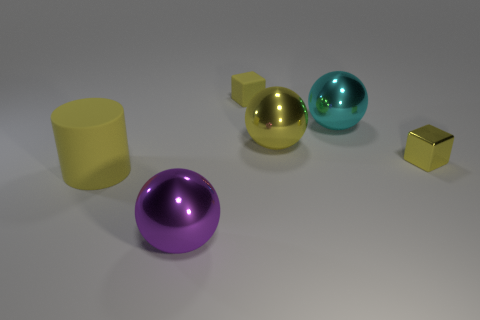There is a large ball that is the same color as the small matte cube; what is its material?
Your answer should be very brief. Metal. Is the number of yellow metal blocks that are on the left side of the purple metallic object the same as the number of matte objects that are to the right of the cylinder?
Provide a succinct answer. No. Is there any other thing that is the same size as the yellow matte cylinder?
Offer a terse response. Yes. There is a cyan object that is the same shape as the big purple object; what is its material?
Your answer should be very brief. Metal. There is a big yellow object that is to the left of the large metal sphere in front of the tiny metal block; are there any big rubber cylinders that are behind it?
Ensure brevity in your answer.  No. There is a small yellow metallic object that is in front of the big yellow metallic ball; is it the same shape as the yellow rubber object behind the large matte cylinder?
Make the answer very short. Yes. Are there more small metallic blocks left of the big purple shiny thing than big yellow cylinders?
Offer a very short reply. No. What number of objects are cyan shiny spheres or purple metal balls?
Give a very brief answer. 2. The big matte thing is what color?
Your answer should be compact. Yellow. How many other objects are there of the same color as the big cylinder?
Provide a succinct answer. 3. 